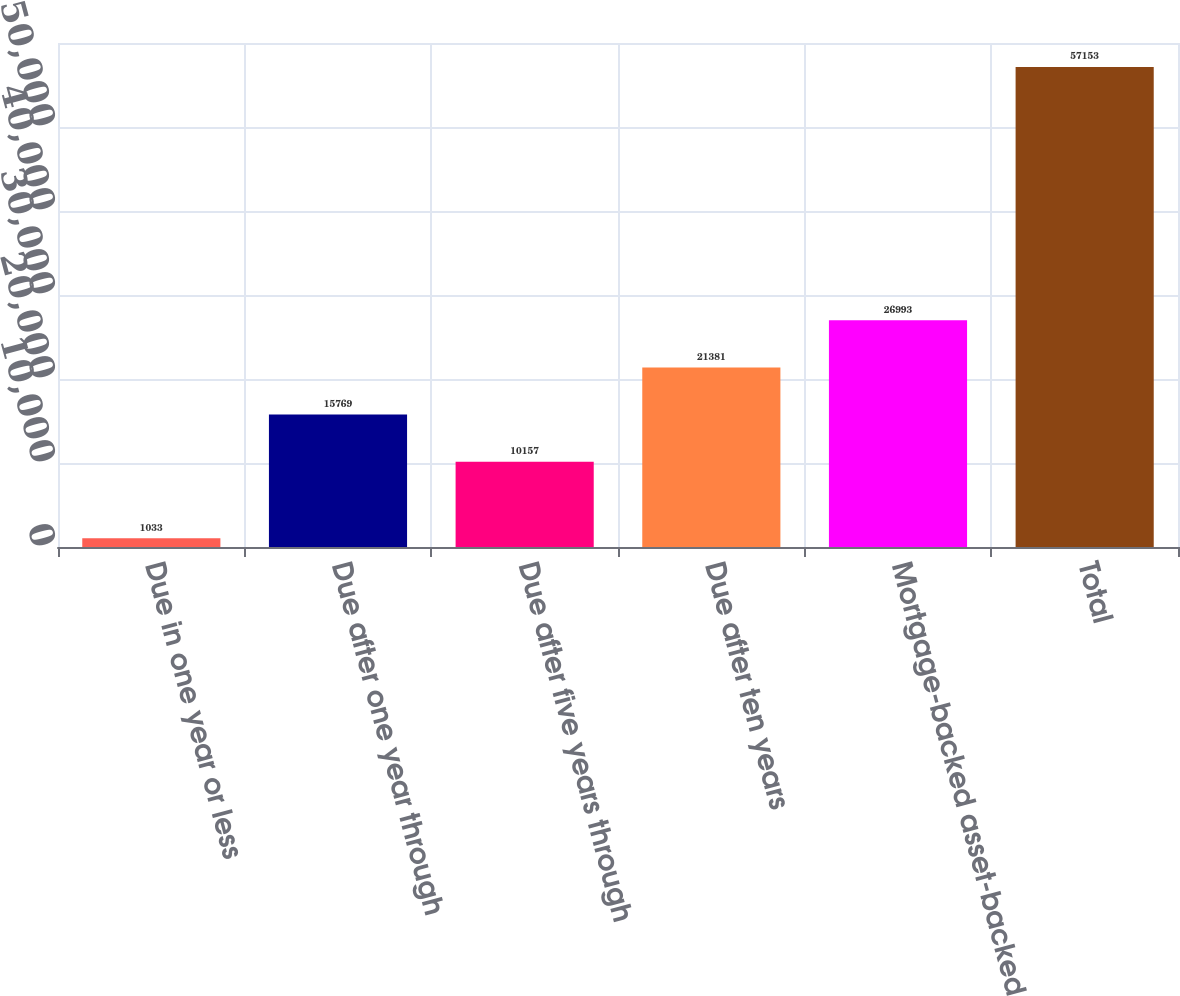Convert chart. <chart><loc_0><loc_0><loc_500><loc_500><bar_chart><fcel>Due in one year or less<fcel>Due after one year through<fcel>Due after five years through<fcel>Due after ten years<fcel>Mortgage-backed asset-backed<fcel>Total<nl><fcel>1033<fcel>15769<fcel>10157<fcel>21381<fcel>26993<fcel>57153<nl></chart> 